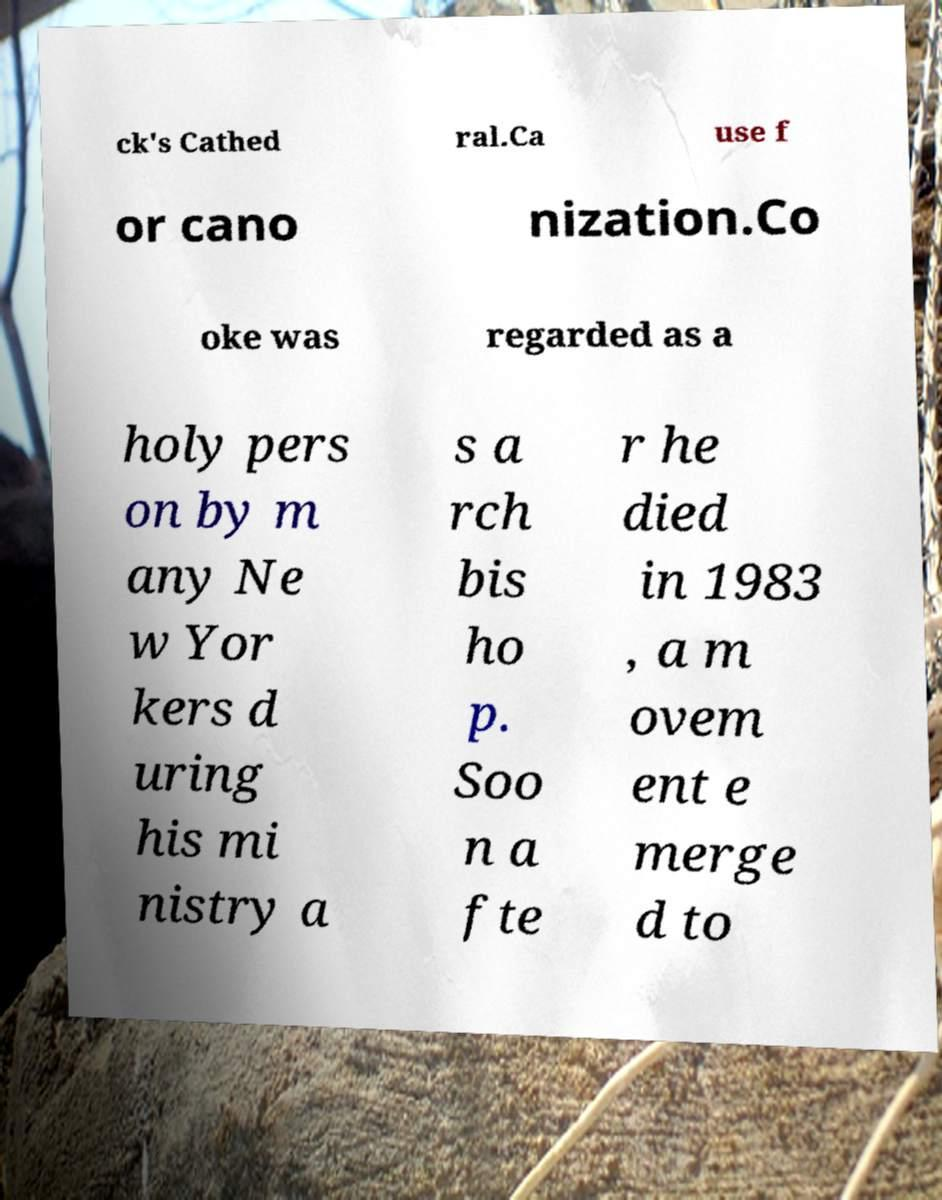There's text embedded in this image that I need extracted. Can you transcribe it verbatim? ck's Cathed ral.Ca use f or cano nization.Co oke was regarded as a holy pers on by m any Ne w Yor kers d uring his mi nistry a s a rch bis ho p. Soo n a fte r he died in 1983 , a m ovem ent e merge d to 